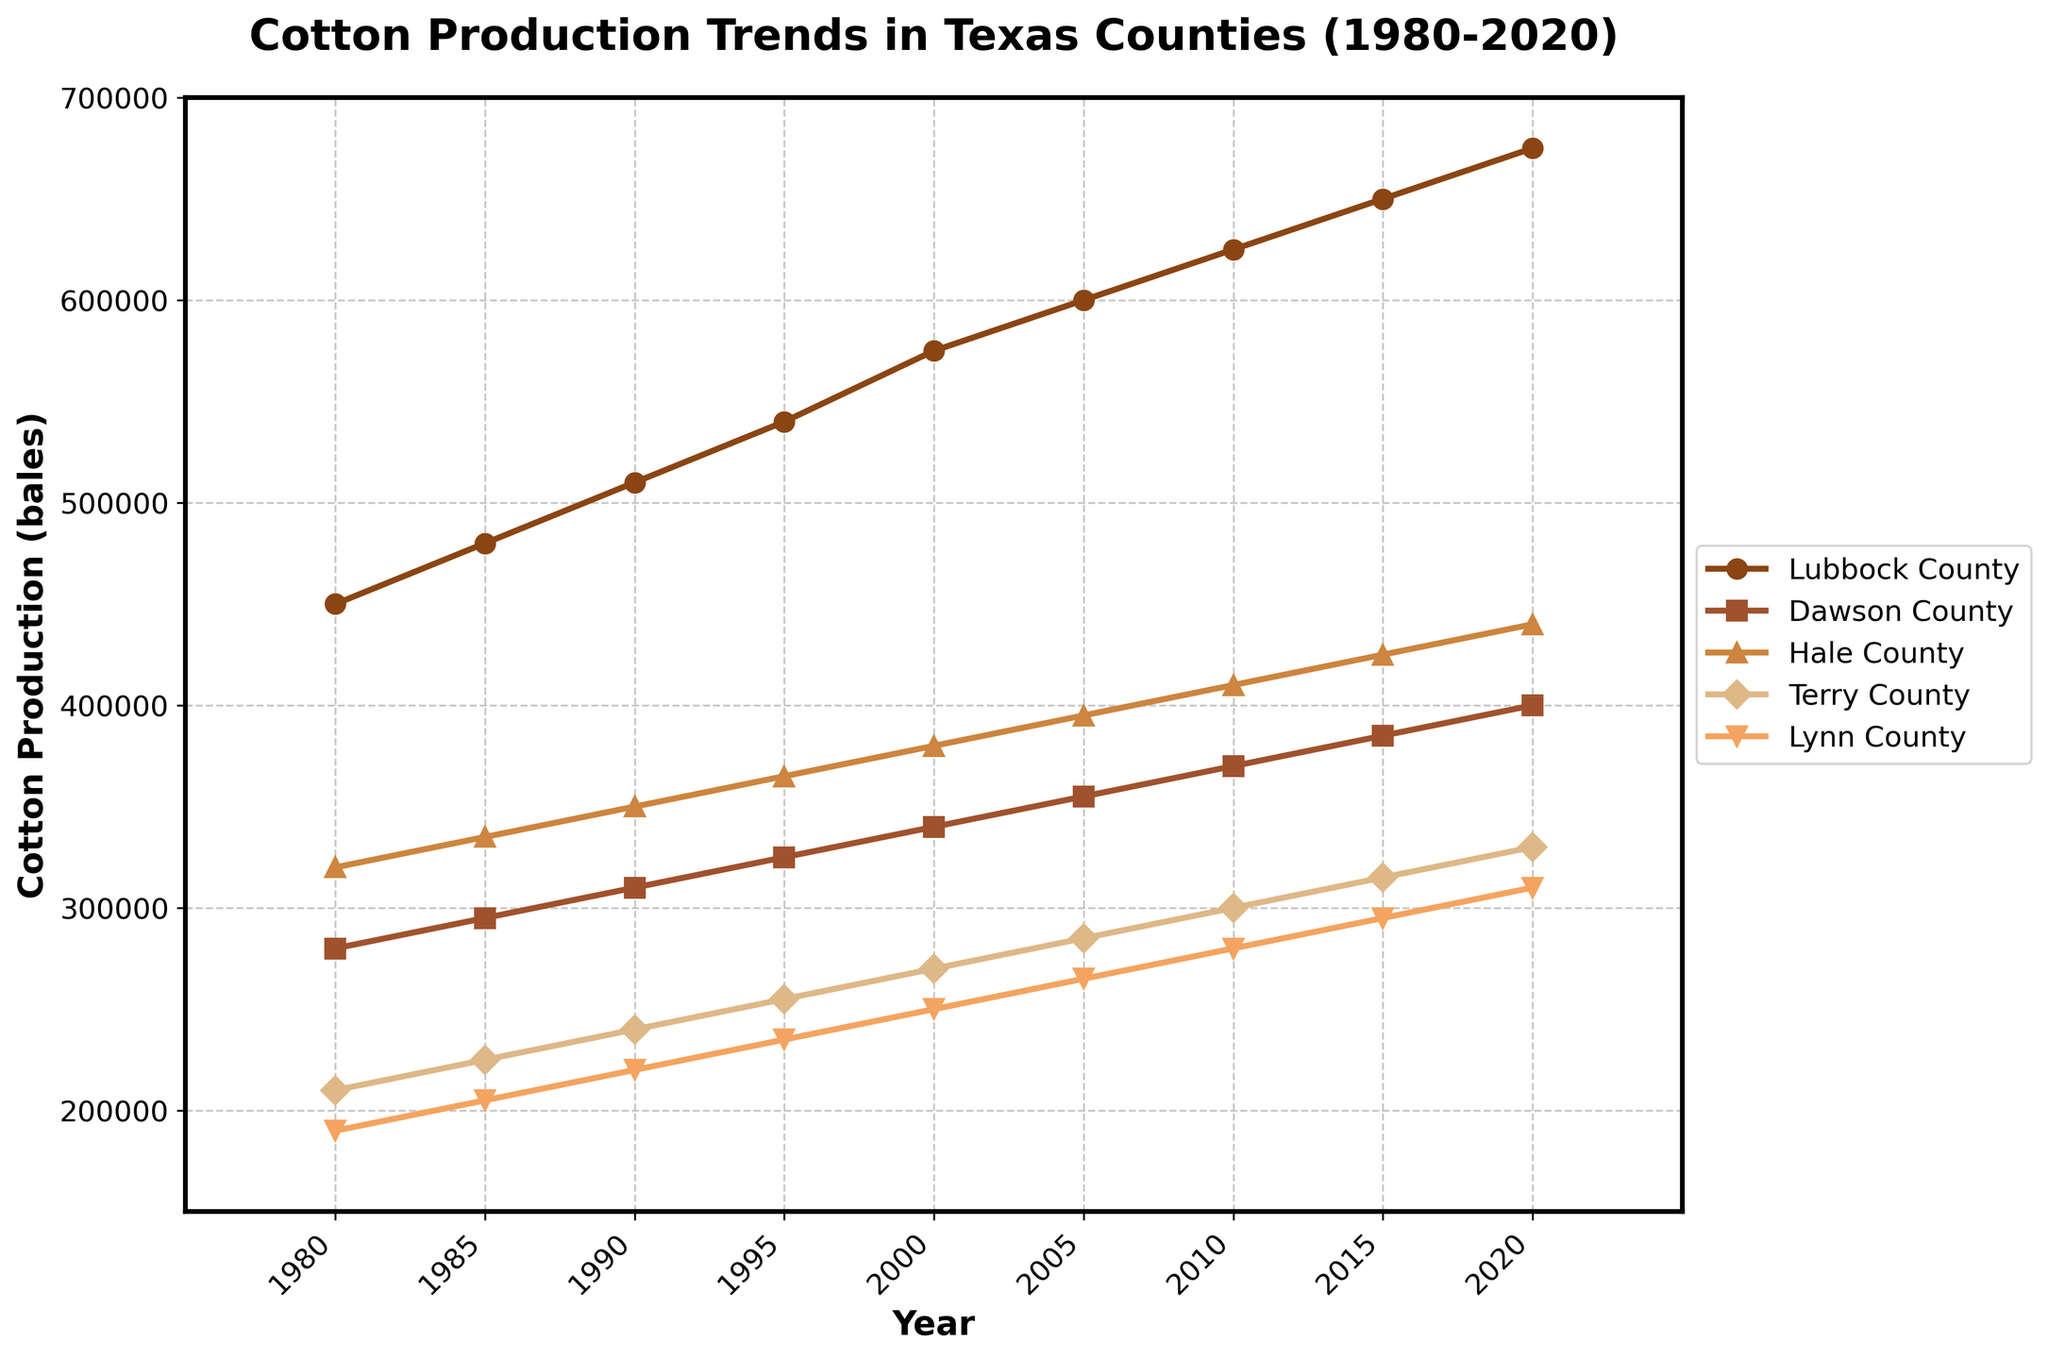Which county had the highest cotton production in 1990? Look at the data points for each county in 1990 and find the maximum value. Lubbock County has the highest, with 510,000 bales.
Answer: Lubbock County Between 1980 and 2000, which county had the smallest increase in cotton production? Calculate the difference in cotton production for each county between 1980 and 2000. Lynn County had the smallest increase, from 190,000 to 250,000, an increase of 60,000 bales.
Answer: Lynn County On average, how many bales of cotton were produced per year in Hale County between 1980 and 2020? Sum the cotton production for Hale County over all years and divide by the number of years. The total is 320,000 + 335,000 + 350,000 + 365,000 + 380,000 + 395,000 + 410,000 + 425,000 + 440,000 = 3,420,000 and there are 9 years, so 3,420,000 / 9 = 380,000 bales per year.
Answer: 380,000 Which county showed a consistent increase in cotton production every five years from 1980 to 2020? Look at the data points for each county and check for consistent increments at each five-year interval. All counties showed a consistent increase.
Answer: All counties By how much did cotton production in Dawson County change from 1985 to 2005? Subtract the production value in 1985 from that in 2005 for Dawson County. In 1985, the production was 295,000 and in 2005 it was 355,000. So, 355,000 - 295,000 = 60,000 bales.
Answer: 60,000 In which year did Lubbock County first produce more than 600,000 bales of cotton? Identify the earliest year when the Lubbock County data point exceeds 600,000. This first occurs in 2005 with 600,000 bales.
Answer: 2005 Which county produced the least amount of cotton in 2010? Check the production values for all counties in 2010. Terry County produced the least with 300,000 bales.
Answer: Terry County How does the trend in Hale County's cotton production compare to that of Terry County from 1980 to 2020? Compare the data points for Hale County and Terry County across the years. Both show an increasing trend, with Hale County starting higher and ending higher compared to Terry County.
Answer: Both increase, Hale County consistently higher What is the average increase in cotton production for Lubbock County every five years? Calculate the differences for each five-year interval and then find the average. Differences are (480,000-450,000) = 30,000, (510,000-480,000) = 30,000, (540,000-510,000) = 30,000, (575,000-540,000) = 35,000, (600,000-575,000) = 25,000, (625,000-600,000) = 25,000, and (650,000-625,000) = 25,000. Average is (30,000 + 30,000 + 30,000 + 35,000 + 25,000 + 25,000 + 25,000)/7 = 28,571.43 bales every five years.
Answer: 28,571.43 bales Considering the highest single-year production for each county, which county had the highest peak production over the 40 years? Identify the maximum value for each county and compare. Lubbock County had the highest peak with 675,000 bales in 2020.
Answer: Lubbock County 